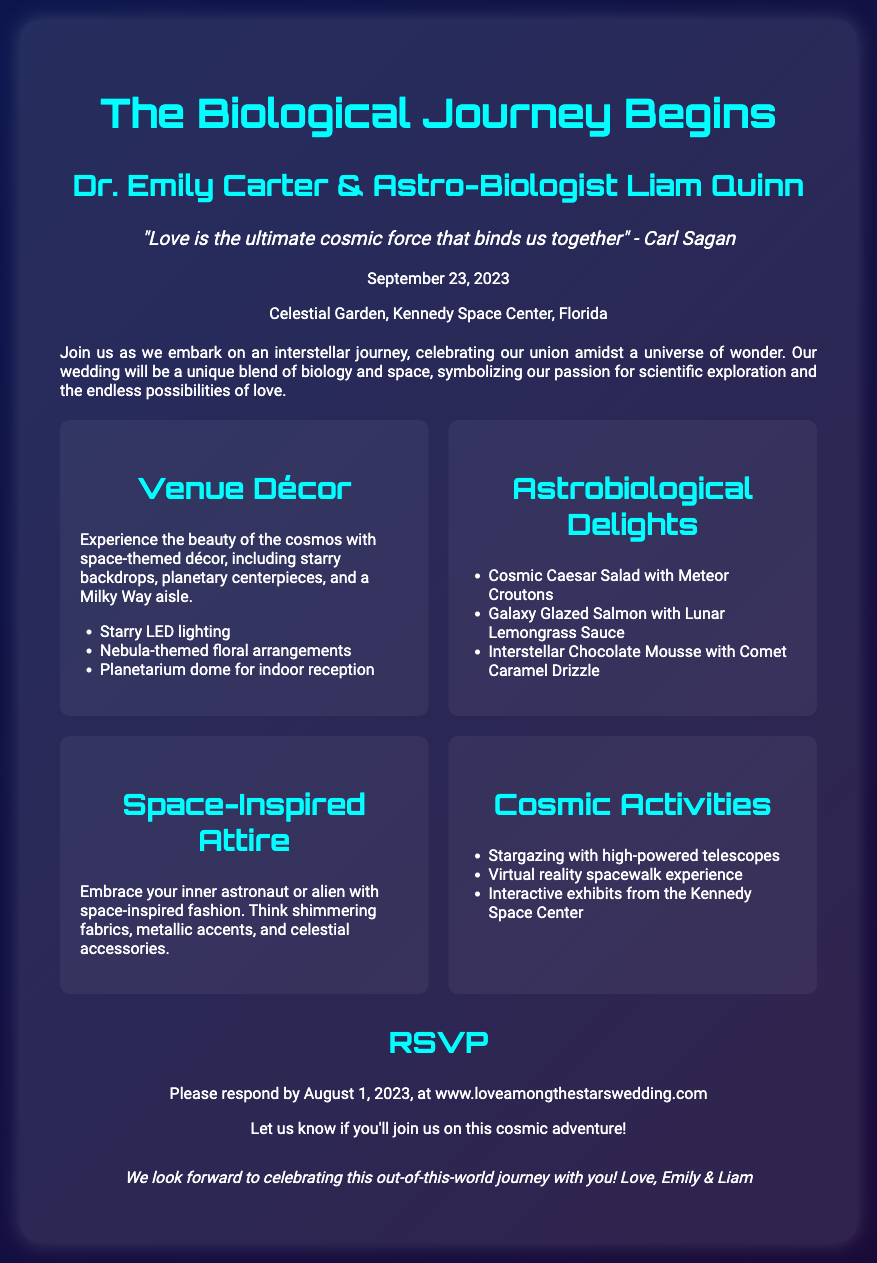What is the date of the wedding? The date of the wedding is mentioned in the details section of the document, which is September 23, 2023.
Answer: September 23, 2023 Who are the couple getting married? The names of the couple getting married are at the top of the wedding invitation, which are Dr. Emily Carter & Astro-Biologist Liam Quinn.
Answer: Dr. Emily Carter & Astro-Biologist Liam Quinn Where is the wedding venue located? The wedding venue is specified in the details, which is the Celestial Garden, Kennedy Space Center, Florida.
Answer: Celestial Garden, Kennedy Space Center, Florida What is one type of cosmic activity mentioned? The document lists various cosmic activities, one of which is Stargazing with high-powered telescopes.
Answer: Stargazing with high-powered telescopes When is the RSVP due? The RSVP deadline is indicated in the RSVP section of the document, which is by August 1, 2023.
Answer: August 1, 2023 What quote is featured in the invitation? The quote is provided in the quote section, which is attributed to Carl Sagan.
Answer: "Love is the ultimate cosmic force that binds us together" - Carl Sagan What is a space-themed food mentioned? The document includes a list of astrobiological delights, one of which is the Cosmic Caesar Salad with Meteor Croutons.
Answer: Cosmic Caesar Salad with Meteor Croutons What style of attire is suggested? The document suggests a style of attire that is space-inspired with shimmering fabrics and metallic accents.
Answer: Space-inspired with shimmering fabrics and metallic accents 